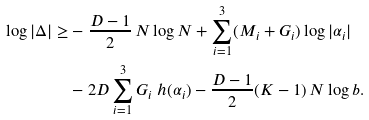Convert formula to latex. <formula><loc_0><loc_0><loc_500><loc_500>\log | \Delta | \geq & - \frac { D - 1 } { 2 } \, N \log N + \sum _ { i = 1 } ^ { 3 } ( M _ { i } + G _ { i } ) \log | \alpha _ { i } | \\ & - 2 D \sum _ { i = 1 } ^ { 3 } G _ { i } \ h ( \alpha _ { i } ) - \frac { D - 1 } { 2 } ( K - 1 ) \, N \log b .</formula> 